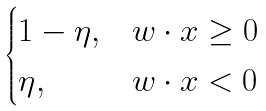<formula> <loc_0><loc_0><loc_500><loc_500>\begin{cases} 1 - \eta , & w \cdot x \geq 0 \\ \eta , & w \cdot x < 0 \end{cases}</formula> 